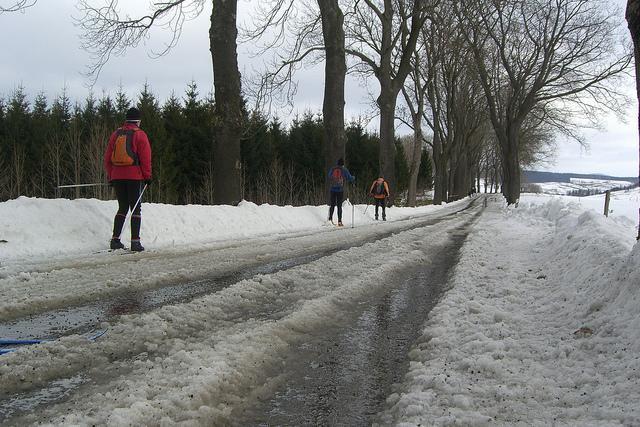How many bears are wearing a hat in the picture?
Give a very brief answer. 0. 